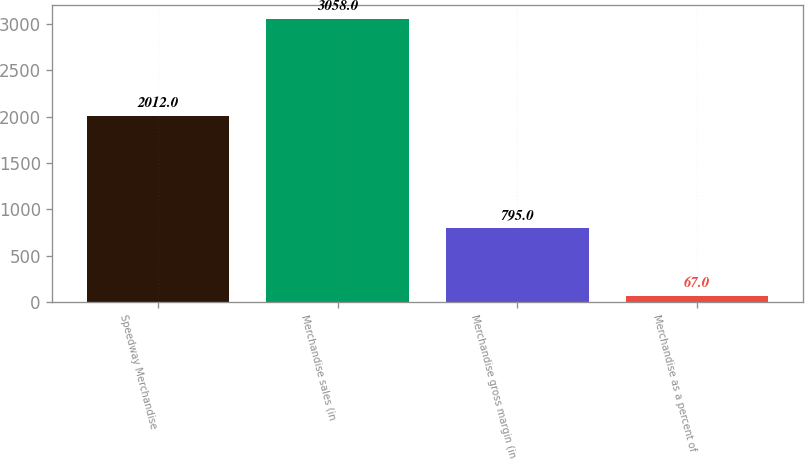<chart> <loc_0><loc_0><loc_500><loc_500><bar_chart><fcel>Speedway Merchandise<fcel>Merchandise sales (in<fcel>Merchandise gross margin (in<fcel>Merchandise as a percent of<nl><fcel>2012<fcel>3058<fcel>795<fcel>67<nl></chart> 